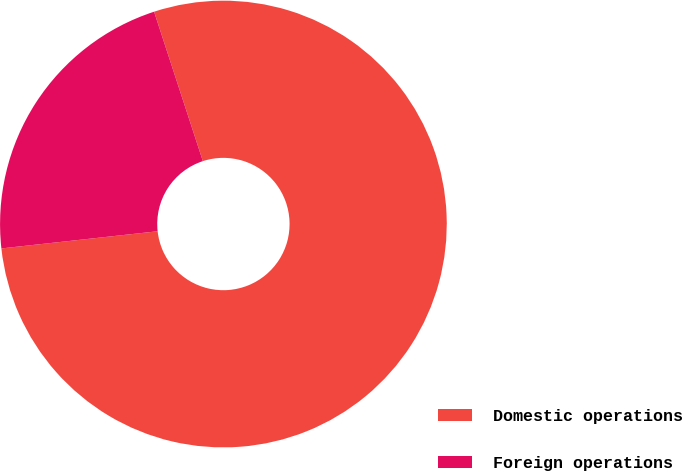<chart> <loc_0><loc_0><loc_500><loc_500><pie_chart><fcel>Domestic operations<fcel>Foreign operations<nl><fcel>78.28%<fcel>21.72%<nl></chart> 